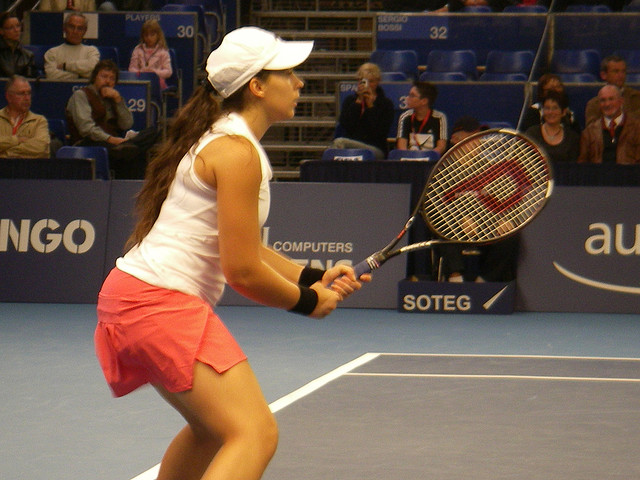Identify the text displayed in this image. SOTEG COMPUTERS 29 30 32 3 SPA P au NGO 